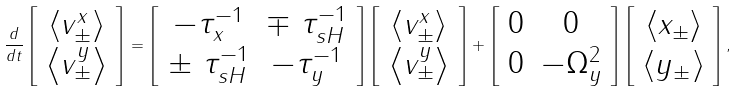<formula> <loc_0><loc_0><loc_500><loc_500>\frac { d } { d t } \left [ \begin{array} { c } \left \langle v _ { \pm } ^ { x } \right \rangle \\ \left \langle v _ { \pm } ^ { y } \right \rangle \end{array} \right ] = \left [ \begin{array} { c c } - \tau _ { x } ^ { - 1 } & \mp \text { } \tau _ { s H } ^ { - 1 } \\ \pm \text { } \tau _ { s H } ^ { - 1 } & - \tau _ { y } ^ { - 1 } \end{array} \right ] \left [ \begin{array} { c } \left \langle v _ { \pm } ^ { x } \right \rangle \\ \left \langle v _ { \pm } ^ { y } \right \rangle \end{array} \right ] + \left [ \begin{array} { c c } 0 & 0 \\ 0 & - \Omega _ { y } ^ { 2 } \end{array} \right ] \left [ \begin{array} { c } \left \langle x _ { \pm } \right \rangle \\ \left \langle y _ { \pm } \right \rangle \end{array} \right ] ,</formula> 